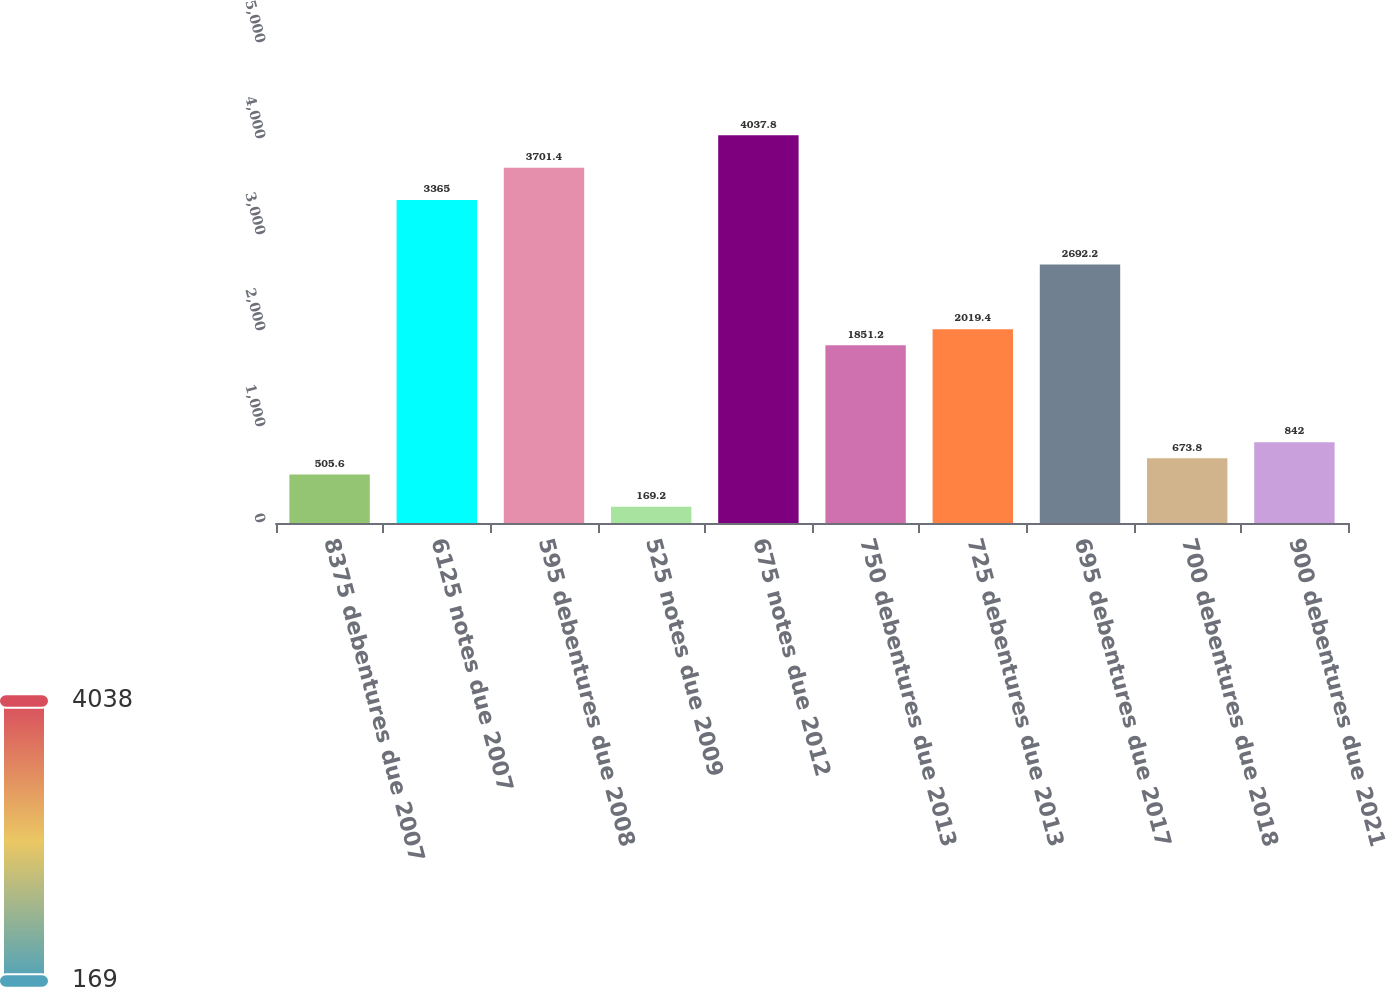Convert chart. <chart><loc_0><loc_0><loc_500><loc_500><bar_chart><fcel>8375 debentures due 2007<fcel>6125 notes due 2007<fcel>595 debentures due 2008<fcel>525 notes due 2009<fcel>675 notes due 2012<fcel>750 debentures due 2013<fcel>725 debentures due 2013<fcel>695 debentures due 2017<fcel>700 debentures due 2018<fcel>900 debentures due 2021<nl><fcel>505.6<fcel>3365<fcel>3701.4<fcel>169.2<fcel>4037.8<fcel>1851.2<fcel>2019.4<fcel>2692.2<fcel>673.8<fcel>842<nl></chart> 